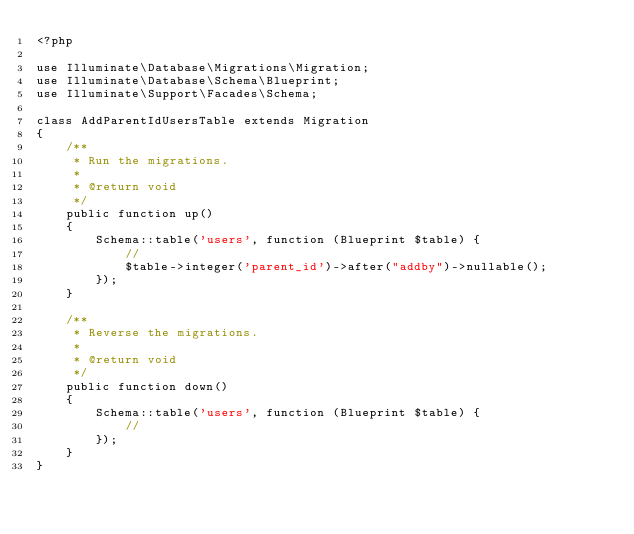<code> <loc_0><loc_0><loc_500><loc_500><_PHP_><?php

use Illuminate\Database\Migrations\Migration;
use Illuminate\Database\Schema\Blueprint;
use Illuminate\Support\Facades\Schema;

class AddParentIdUsersTable extends Migration
{
    /**
     * Run the migrations.
     *
     * @return void
     */
    public function up()
    {
        Schema::table('users', function (Blueprint $table) {
            //
            $table->integer('parent_id')->after("addby")->nullable();
        });
    }

    /**
     * Reverse the migrations.
     *
     * @return void
     */
    public function down()
    {
        Schema::table('users', function (Blueprint $table) {
            //
        });
    }
}
</code> 